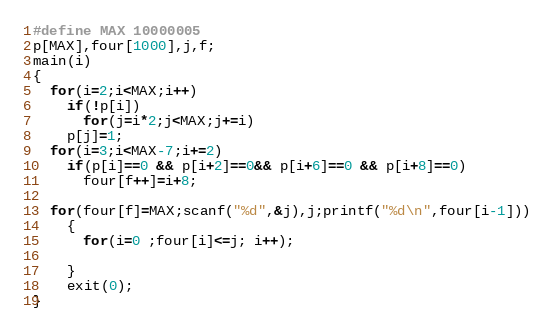<code> <loc_0><loc_0><loc_500><loc_500><_C_>#define MAX 10000005
p[MAX],four[1000],j,f;
main(i)
{
  for(i=2;i<MAX;i++)
    if(!p[i])
      for(j=i*2;j<MAX;j+=i)
	p[j]=1;
  for(i=3;i<MAX-7;i+=2)
    if(p[i]==0 && p[i+2]==0&& p[i+6]==0 && p[i+8]==0)
      four[f++]=i+8;
  
  for(four[f]=MAX;scanf("%d",&j),j;printf("%d\n",four[i-1]))
    {
      for(i=0 ;four[i]<=j; i++);

    }
	exit(0);  
}</code> 